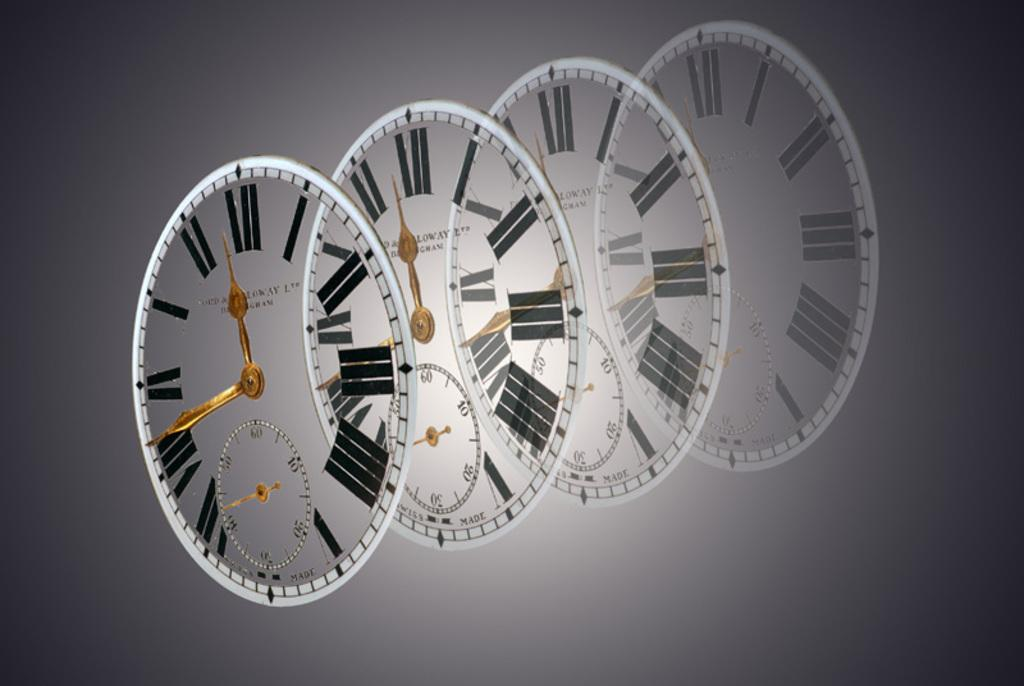Provide a one-sentence caption for the provided image. Four sets of clocks are lined up with two of them with their small hands pointed at 12. 